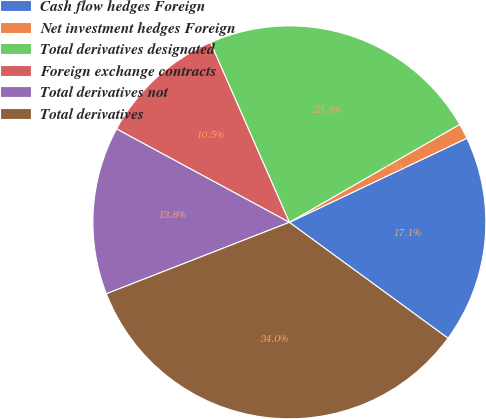Convert chart to OTSL. <chart><loc_0><loc_0><loc_500><loc_500><pie_chart><fcel>Cash flow hedges Foreign<fcel>Net investment hedges Foreign<fcel>Total derivatives designated<fcel>Foreign exchange contracts<fcel>Total derivatives not<fcel>Total derivatives<nl><fcel>17.09%<fcel>1.26%<fcel>23.28%<fcel>10.53%<fcel>13.81%<fcel>34.04%<nl></chart> 